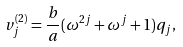<formula> <loc_0><loc_0><loc_500><loc_500>v _ { j } ^ { ( 2 ) } = \frac { b } { a } ( \omega ^ { 2 j } + \omega ^ { j } + 1 ) q _ { j } ,</formula> 